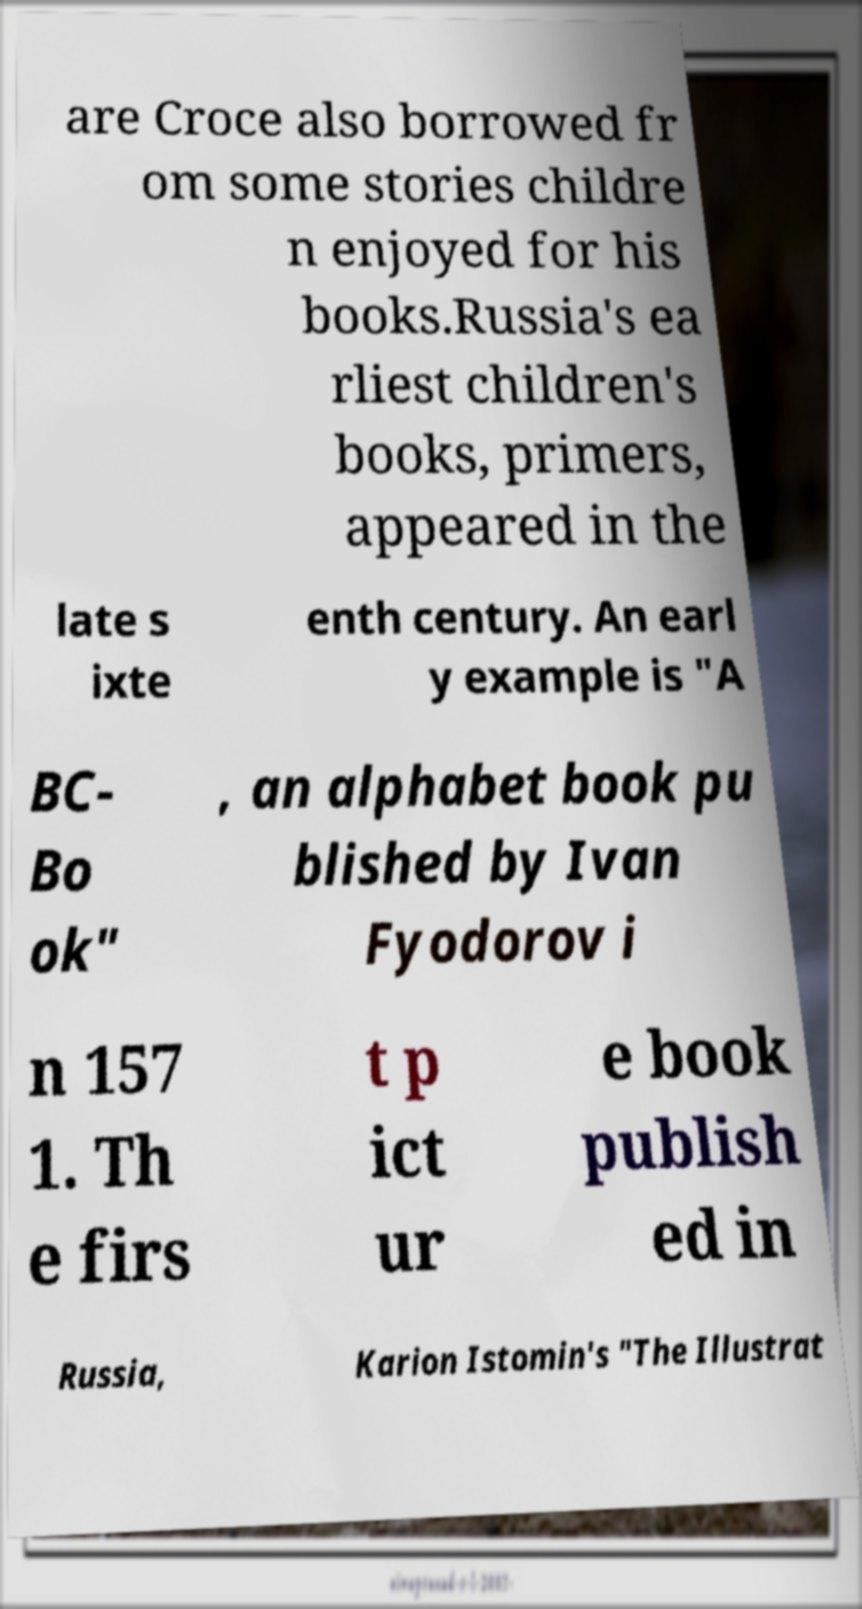Could you assist in decoding the text presented in this image and type it out clearly? are Croce also borrowed fr om some stories childre n enjoyed for his books.Russia's ea rliest children's books, primers, appeared in the late s ixte enth century. An earl y example is "A BC- Bo ok" , an alphabet book pu blished by Ivan Fyodorov i n 157 1. Th e firs t p ict ur e book publish ed in Russia, Karion Istomin's "The Illustrat 